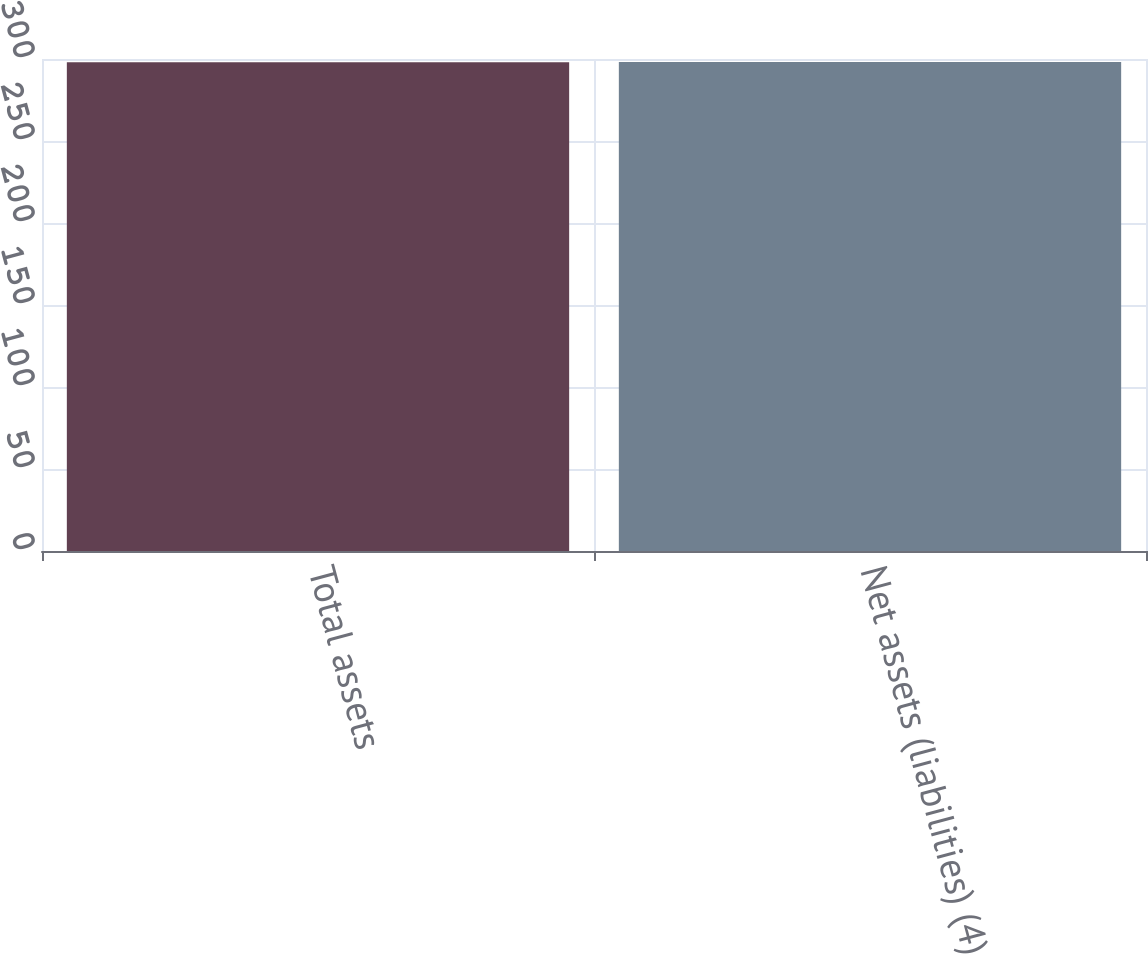Convert chart to OTSL. <chart><loc_0><loc_0><loc_500><loc_500><bar_chart><fcel>Total assets<fcel>Net assets (liabilities) (4)<nl><fcel>298<fcel>298.1<nl></chart> 